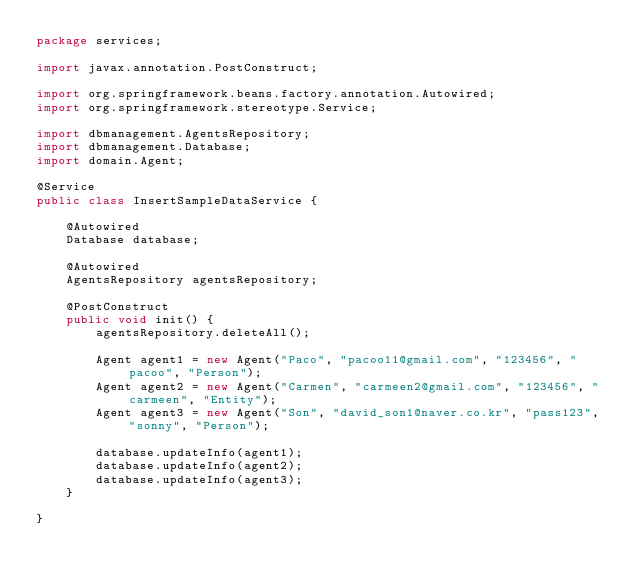Convert code to text. <code><loc_0><loc_0><loc_500><loc_500><_Java_>package services;

import javax.annotation.PostConstruct;

import org.springframework.beans.factory.annotation.Autowired;
import org.springframework.stereotype.Service;

import dbmanagement.AgentsRepository;
import dbmanagement.Database;
import domain.Agent;

@Service
public class InsertSampleDataService {
	
	@Autowired
	Database database;
	
	@Autowired
	AgentsRepository agentsRepository;
	
	@PostConstruct
	public void init() {
		agentsRepository.deleteAll();
		
		Agent agent1 = new Agent("Paco", "pacoo11@gmail.com", "123456", "pacoo", "Person");
		Agent agent2 = new Agent("Carmen", "carmeen2@gmail.com", "123456", "carmeen", "Entity");
		Agent agent3 = new Agent("Son", "david_son1@naver.co.kr", "pass123", "sonny", "Person");
		
		database.updateInfo(agent1);
		database.updateInfo(agent2);
		database.updateInfo(agent3);
	}

}
</code> 